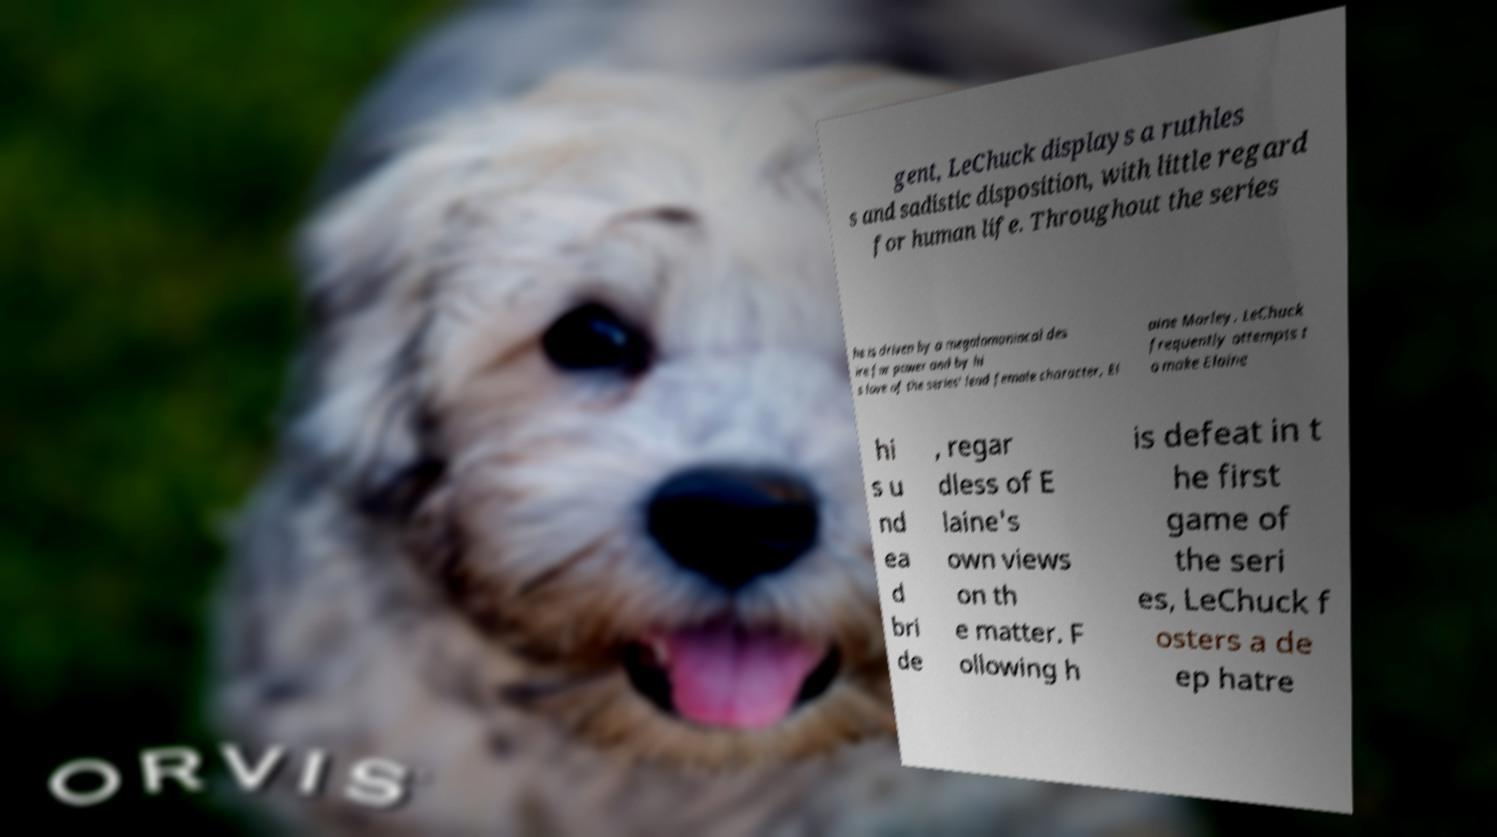There's text embedded in this image that I need extracted. Can you transcribe it verbatim? gent, LeChuck displays a ruthles s and sadistic disposition, with little regard for human life. Throughout the series he is driven by a megalomaniacal des ire for power and by hi s love of the series' lead female character, El aine Marley. LeChuck frequently attempts t o make Elaine hi s u nd ea d bri de , regar dless of E laine's own views on th e matter. F ollowing h is defeat in t he first game of the seri es, LeChuck f osters a de ep hatre 